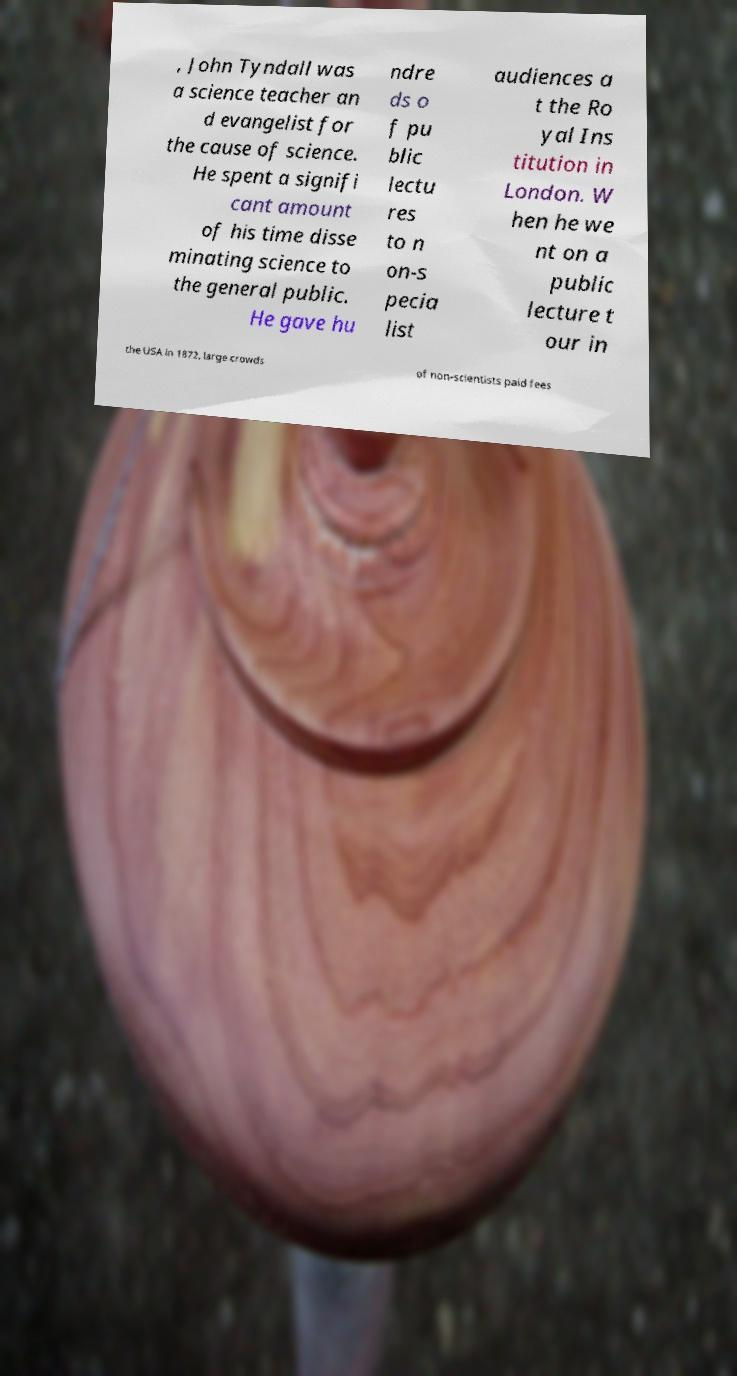Can you read and provide the text displayed in the image?This photo seems to have some interesting text. Can you extract and type it out for me? , John Tyndall was a science teacher an d evangelist for the cause of science. He spent a signifi cant amount of his time disse minating science to the general public. He gave hu ndre ds o f pu blic lectu res to n on-s pecia list audiences a t the Ro yal Ins titution in London. W hen he we nt on a public lecture t our in the USA in 1872, large crowds of non-scientists paid fees 